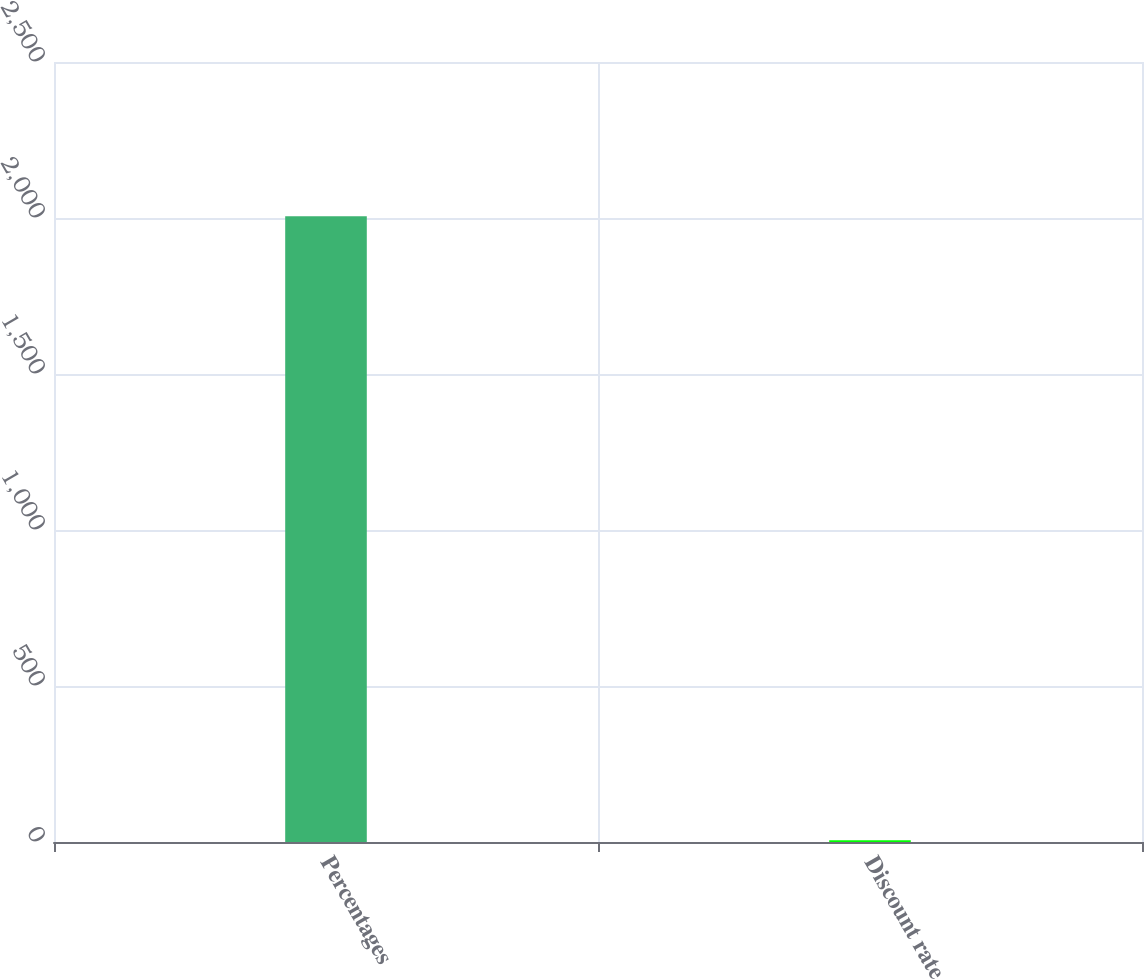Convert chart to OTSL. <chart><loc_0><loc_0><loc_500><loc_500><bar_chart><fcel>Percentages<fcel>Discount rate<nl><fcel>2006<fcel>6<nl></chart> 